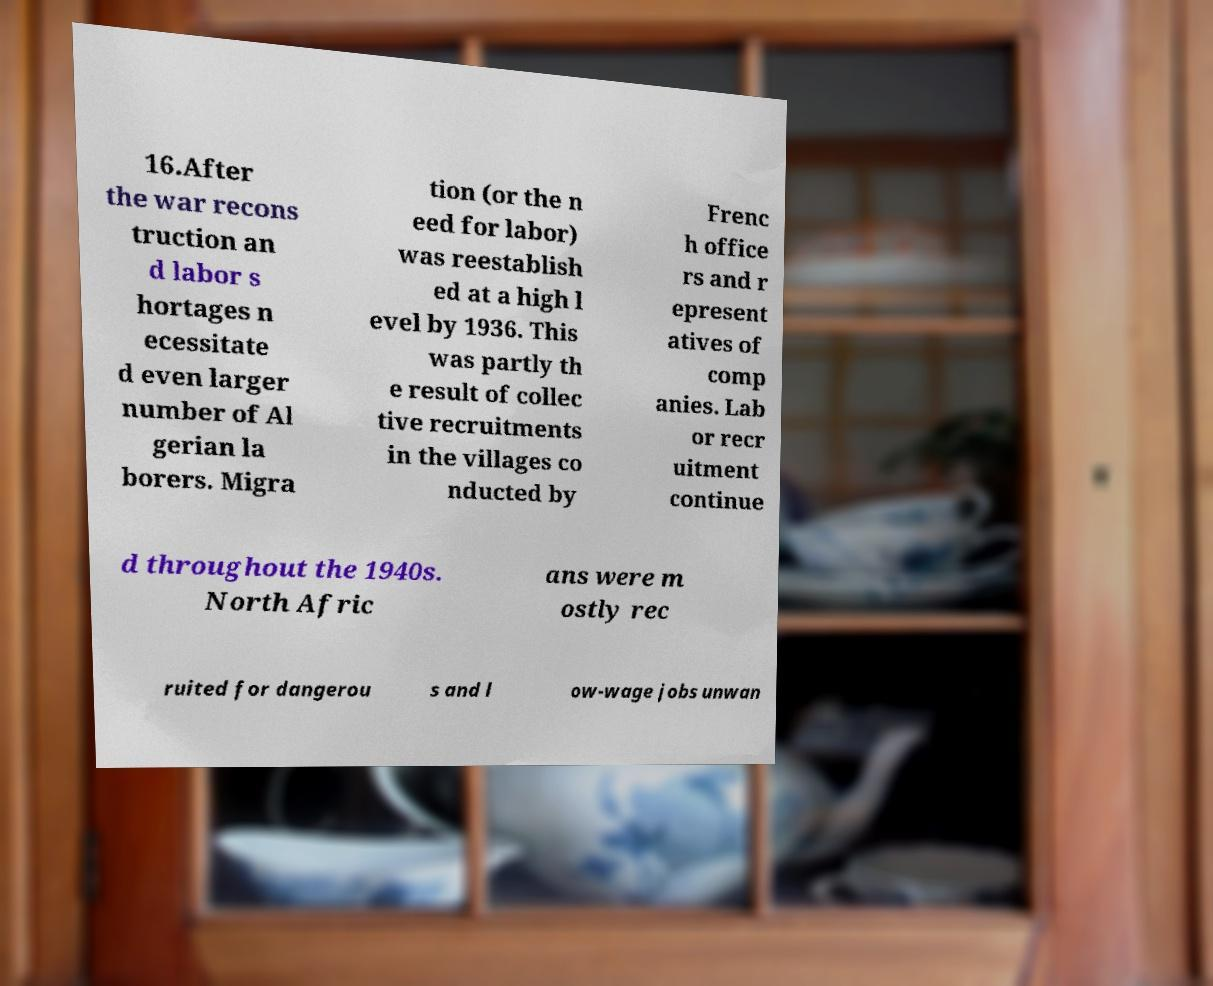Please read and relay the text visible in this image. What does it say? 16.After the war recons truction an d labor s hortages n ecessitate d even larger number of Al gerian la borers. Migra tion (or the n eed for labor) was reestablish ed at a high l evel by 1936. This was partly th e result of collec tive recruitments in the villages co nducted by Frenc h office rs and r epresent atives of comp anies. Lab or recr uitment continue d throughout the 1940s. North Afric ans were m ostly rec ruited for dangerou s and l ow-wage jobs unwan 